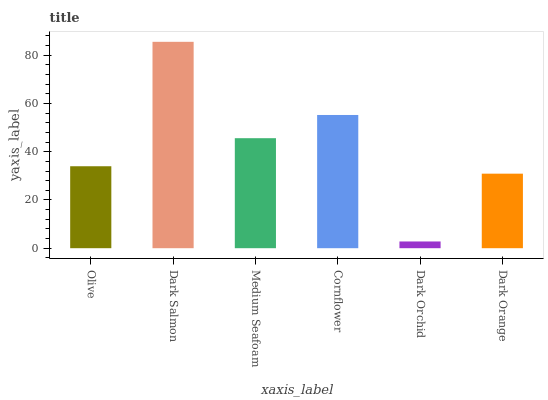Is Dark Orchid the minimum?
Answer yes or no. Yes. Is Dark Salmon the maximum?
Answer yes or no. Yes. Is Medium Seafoam the minimum?
Answer yes or no. No. Is Medium Seafoam the maximum?
Answer yes or no. No. Is Dark Salmon greater than Medium Seafoam?
Answer yes or no. Yes. Is Medium Seafoam less than Dark Salmon?
Answer yes or no. Yes. Is Medium Seafoam greater than Dark Salmon?
Answer yes or no. No. Is Dark Salmon less than Medium Seafoam?
Answer yes or no. No. Is Medium Seafoam the high median?
Answer yes or no. Yes. Is Olive the low median?
Answer yes or no. Yes. Is Dark Salmon the high median?
Answer yes or no. No. Is Dark Orchid the low median?
Answer yes or no. No. 